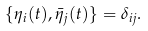Convert formula to latex. <formula><loc_0><loc_0><loc_500><loc_500>\{ \eta _ { i } ( t ) , \bar { \eta } _ { j } ( t ) \} = \delta _ { i j } .</formula> 